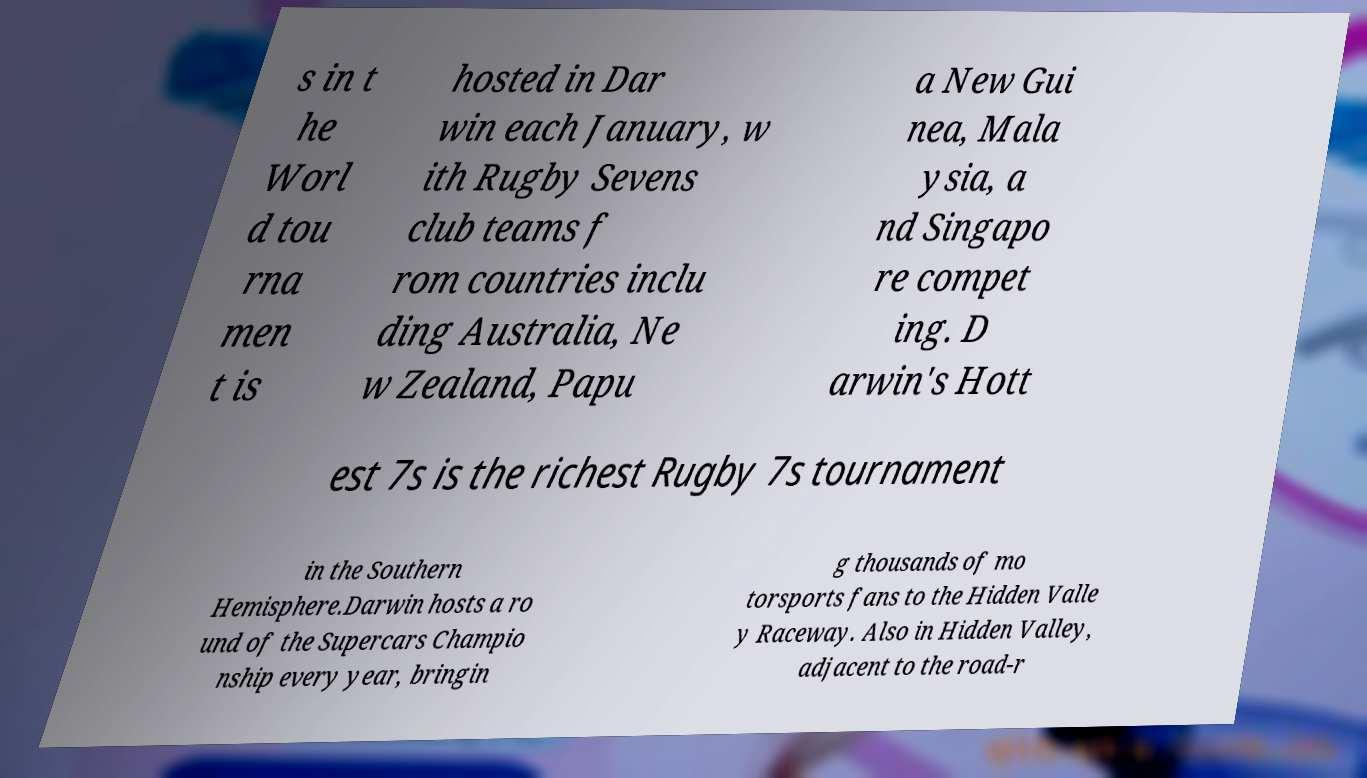Can you read and provide the text displayed in the image?This photo seems to have some interesting text. Can you extract and type it out for me? s in t he Worl d tou rna men t is hosted in Dar win each January, w ith Rugby Sevens club teams f rom countries inclu ding Australia, Ne w Zealand, Papu a New Gui nea, Mala ysia, a nd Singapo re compet ing. D arwin's Hott est 7s is the richest Rugby 7s tournament in the Southern Hemisphere.Darwin hosts a ro und of the Supercars Champio nship every year, bringin g thousands of mo torsports fans to the Hidden Valle y Raceway. Also in Hidden Valley, adjacent to the road-r 